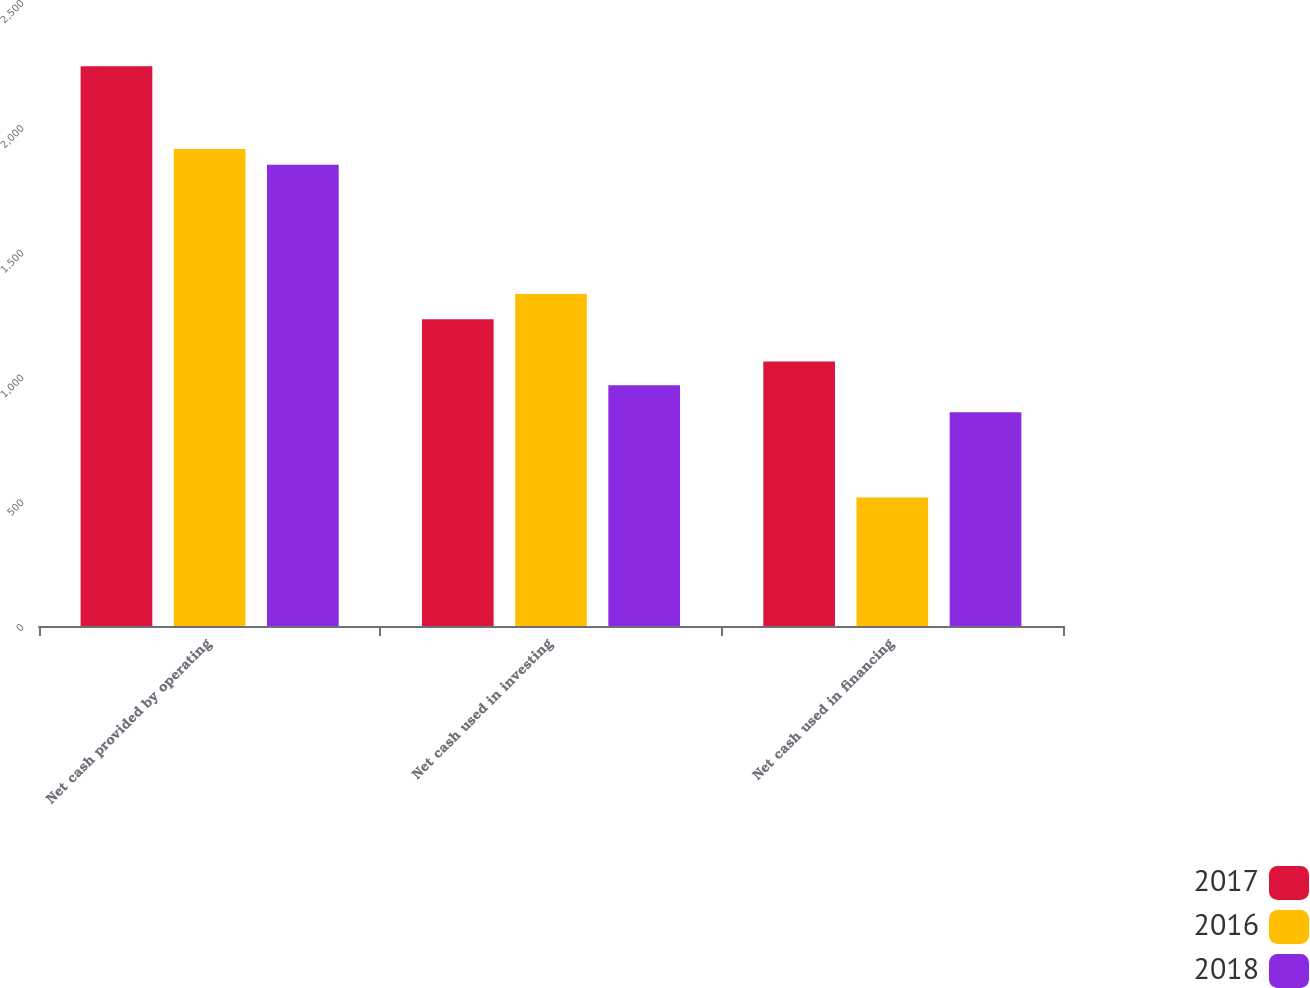Convert chart to OTSL. <chart><loc_0><loc_0><loc_500><loc_500><stacked_bar_chart><ecel><fcel>Net cash provided by operating<fcel>Net cash used in investing<fcel>Net cash used in financing<nl><fcel>2017<fcel>2242.8<fcel>1229.1<fcel>1059.5<nl><fcel>2016<fcel>1910.7<fcel>1330.2<fcel>514.4<nl><fcel>2018<fcel>1847.8<fcel>964.5<fcel>856.8<nl></chart> 